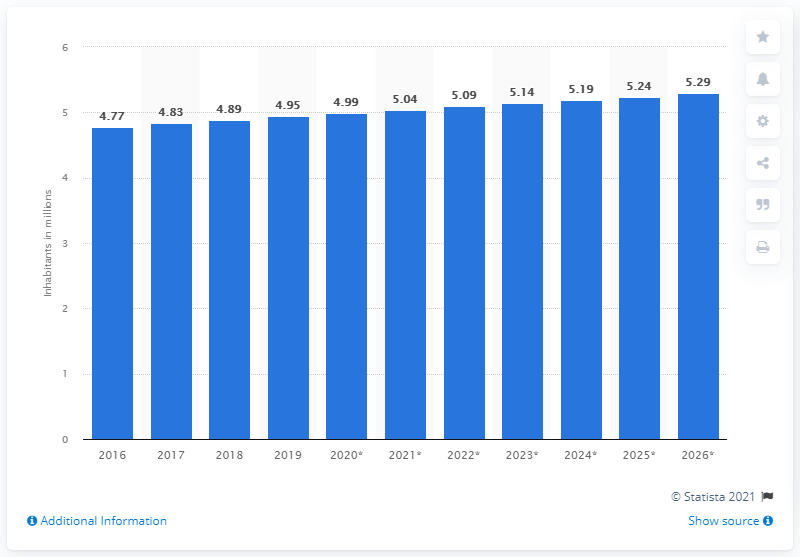Outline some significant characteristics in this image. In 2019, Ireland's population was approximately 4.99 million people. 